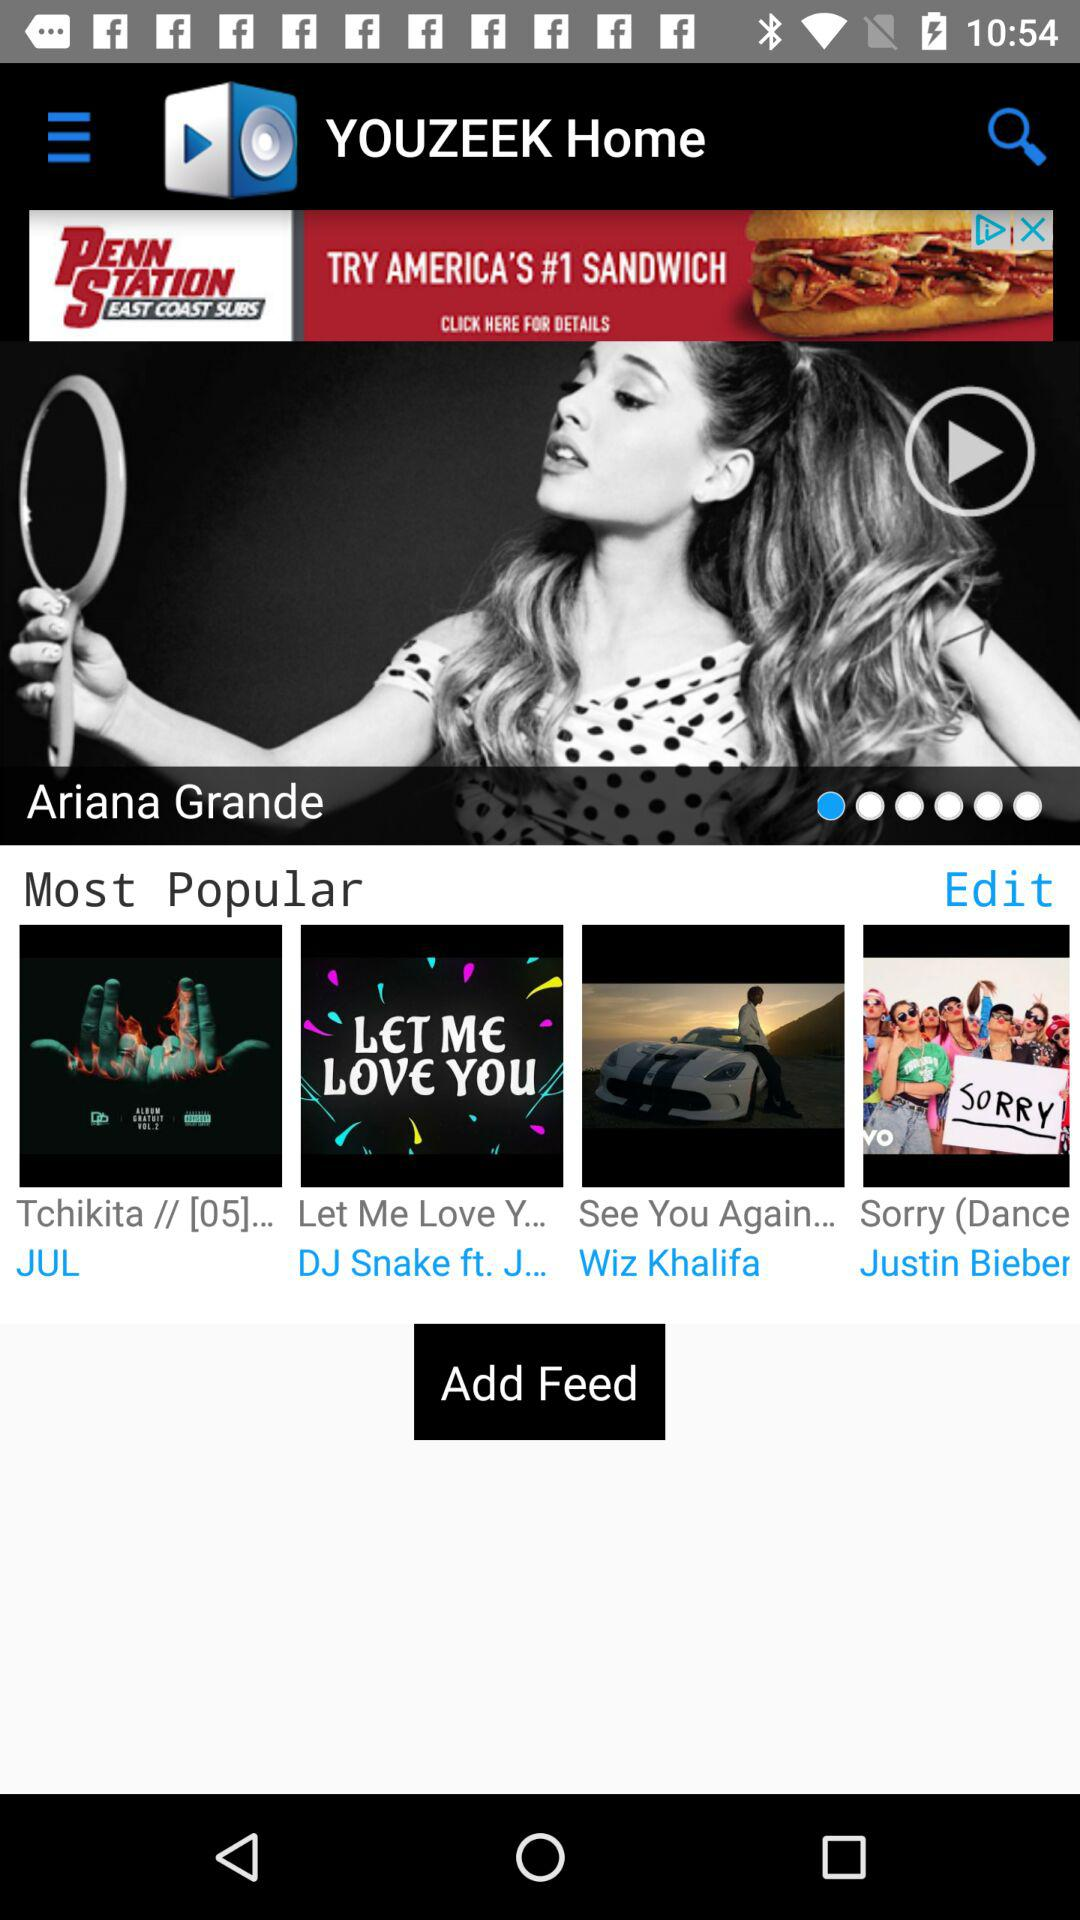What is the app name? The app name is "YOUZEEK Home". 